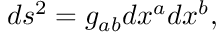Convert formula to latex. <formula><loc_0><loc_0><loc_500><loc_500>d s ^ { 2 } = g _ { a b } d x ^ { a } d x ^ { b } ,</formula> 